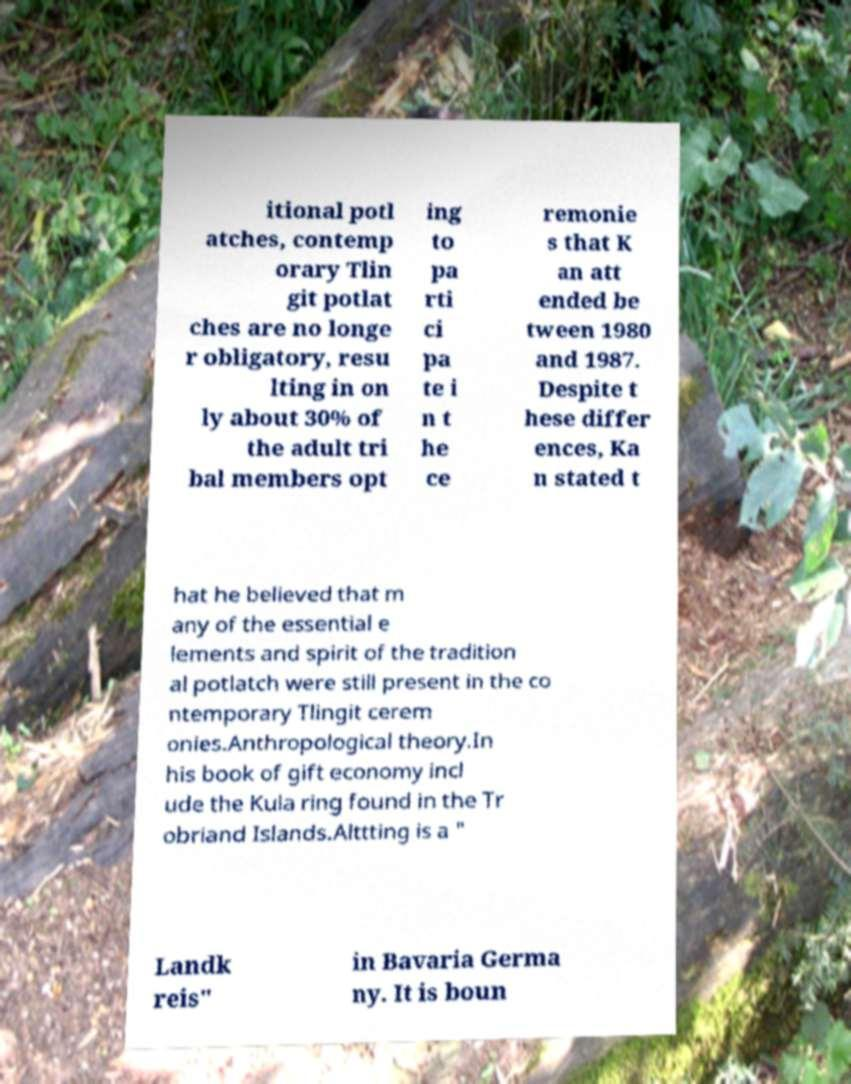Please identify and transcribe the text found in this image. itional potl atches, contemp orary Tlin git potlat ches are no longe r obligatory, resu lting in on ly about 30% of the adult tri bal members opt ing to pa rti ci pa te i n t he ce remonie s that K an att ended be tween 1980 and 1987. Despite t hese differ ences, Ka n stated t hat he believed that m any of the essential e lements and spirit of the tradition al potlatch were still present in the co ntemporary Tlingit cerem onies.Anthropological theory.In his book of gift economy incl ude the Kula ring found in the Tr obriand Islands.Alttting is a " Landk reis" in Bavaria Germa ny. It is boun 